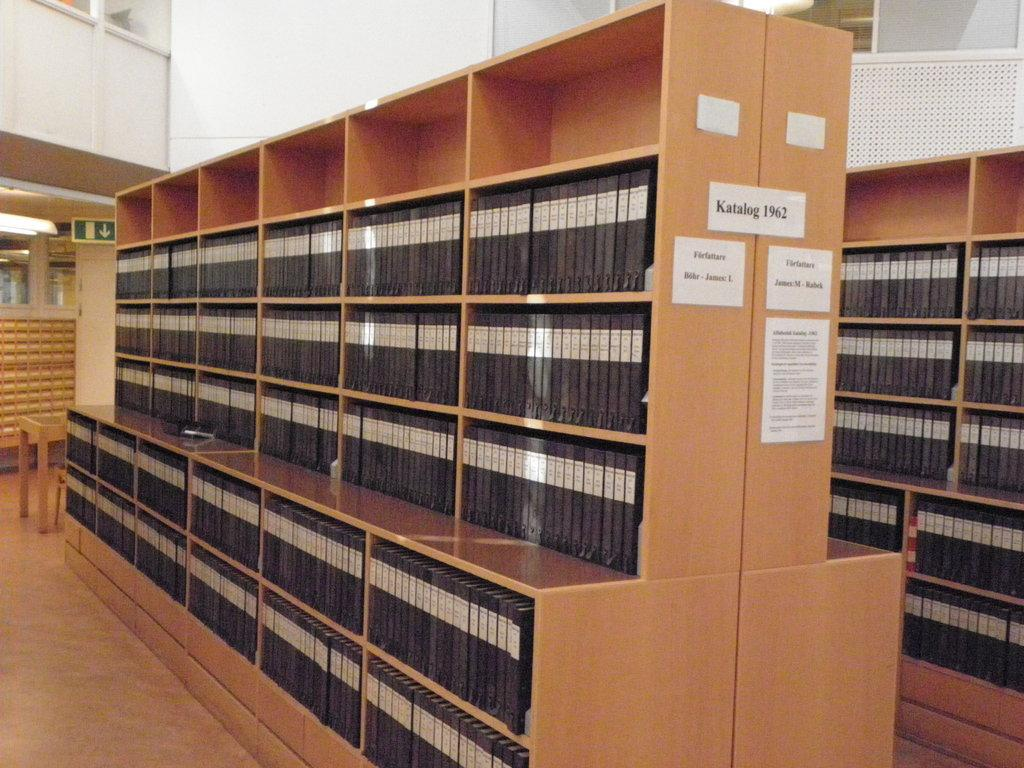<image>
Render a clear and concise summary of the photo. A large quantity of books are arranged on a book shelf with the tag katalog 1962 on the middle of the shelves. 